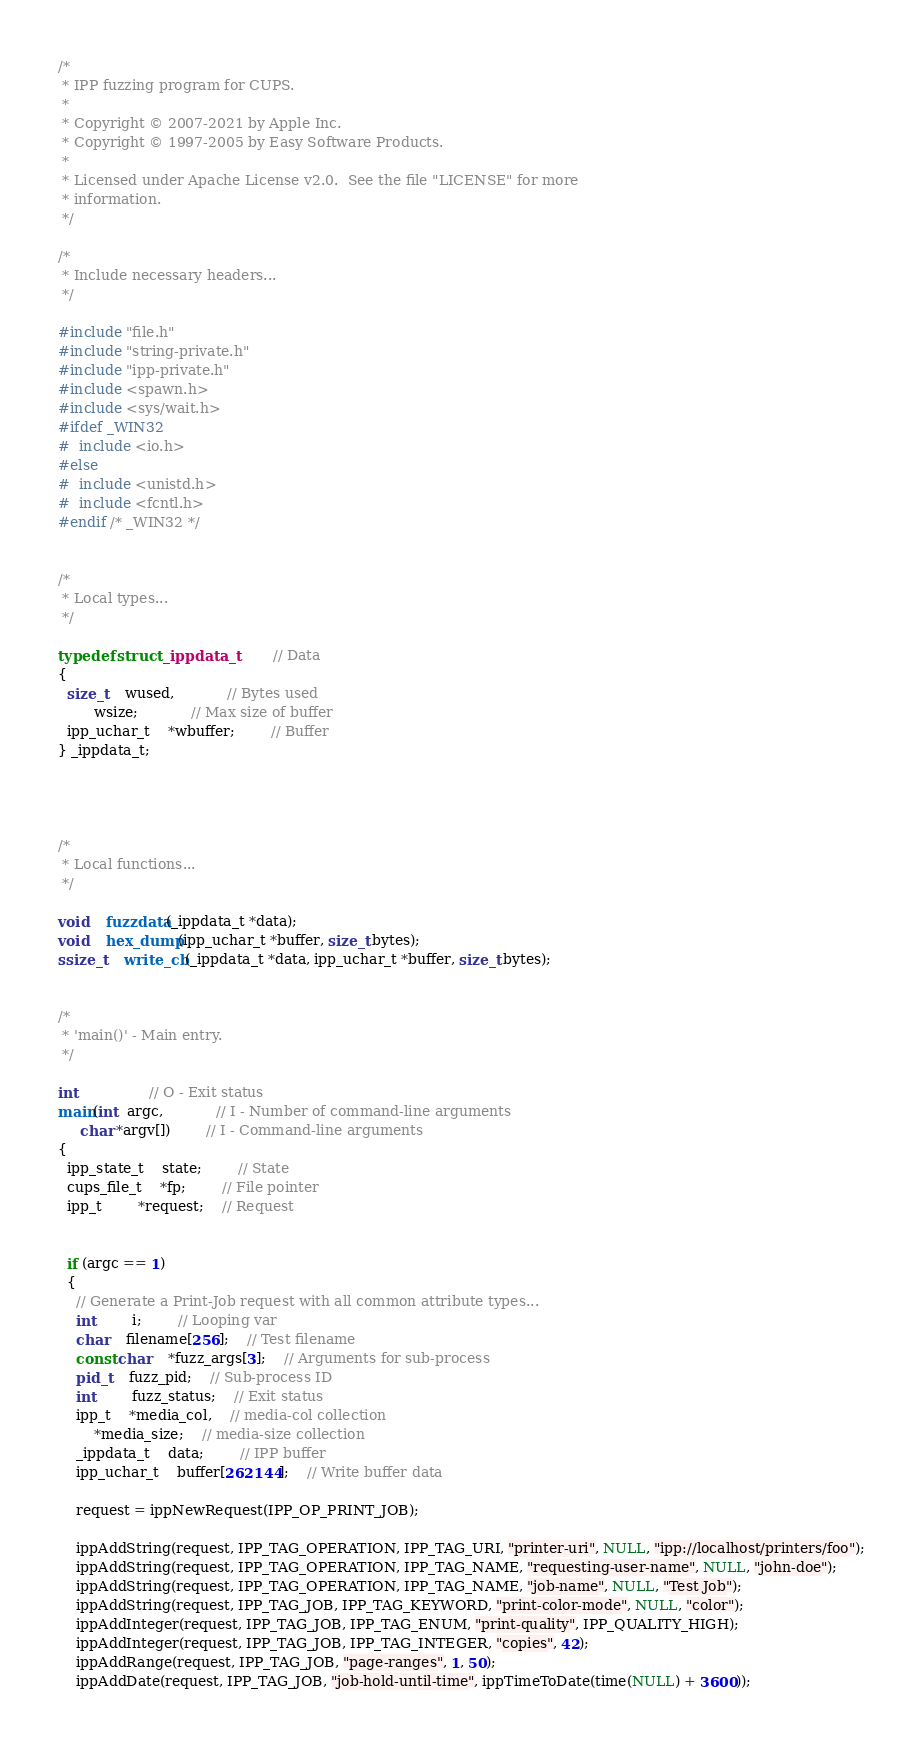Convert code to text. <code><loc_0><loc_0><loc_500><loc_500><_C_>/*
 * IPP fuzzing program for CUPS.
 *
 * Copyright © 2007-2021 by Apple Inc.
 * Copyright © 1997-2005 by Easy Software Products.
 *
 * Licensed under Apache License v2.0.  See the file "LICENSE" for more
 * information.
 */

/*
 * Include necessary headers...
 */

#include "file.h"
#include "string-private.h"
#include "ipp-private.h"
#include <spawn.h>
#include <sys/wait.h>
#ifdef _WIN32
#  include <io.h>
#else
#  include <unistd.h>
#  include <fcntl.h>
#endif /* _WIN32 */


/*
 * Local types...
 */

typedef struct _ippdata_t		// Data 
{
  size_t	wused,			// Bytes used
		wsize;			// Max size of buffer
  ipp_uchar_t	*wbuffer;		// Buffer
} _ippdata_t;




/*
 * Local functions...
 */

void	fuzzdata(_ippdata_t *data);
void	hex_dump(ipp_uchar_t *buffer, size_t bytes);
ssize_t	write_cb(_ippdata_t *data, ipp_uchar_t *buffer, size_t bytes);


/*
 * 'main()' - Main entry.
 */

int				// O - Exit status
main(int  argc,			// I - Number of command-line arguments
     char *argv[])		// I - Command-line arguments
{
  ipp_state_t	state;		// State
  cups_file_t	*fp;		// File pointer
  ipp_t		*request;	// Request


  if (argc == 1)
  {
    // Generate a Print-Job request with all common attribute types...
    int		i;		// Looping var
    char	filename[256];	// Test filename
    const char	*fuzz_args[3];	// Arguments for sub-process
    pid_t	fuzz_pid;	// Sub-process ID
    int		fuzz_status;	// Exit status
    ipp_t	*media_col,	// media-col collection
		*media_size;	// media-size collection
    _ippdata_t	data;		// IPP buffer
    ipp_uchar_t	buffer[262144];	// Write buffer data

    request = ippNewRequest(IPP_OP_PRINT_JOB);

    ippAddString(request, IPP_TAG_OPERATION, IPP_TAG_URI, "printer-uri", NULL, "ipp://localhost/printers/foo");
    ippAddString(request, IPP_TAG_OPERATION, IPP_TAG_NAME, "requesting-user-name", NULL, "john-doe");
    ippAddString(request, IPP_TAG_OPERATION, IPP_TAG_NAME, "job-name", NULL, "Test Job");
    ippAddString(request, IPP_TAG_JOB, IPP_TAG_KEYWORD, "print-color-mode", NULL, "color");
    ippAddInteger(request, IPP_TAG_JOB, IPP_TAG_ENUM, "print-quality", IPP_QUALITY_HIGH);
    ippAddInteger(request, IPP_TAG_JOB, IPP_TAG_INTEGER, "copies", 42);
    ippAddRange(request, IPP_TAG_JOB, "page-ranges", 1, 50);
    ippAddDate(request, IPP_TAG_JOB, "job-hold-until-time", ippTimeToDate(time(NULL) + 3600));</code> 